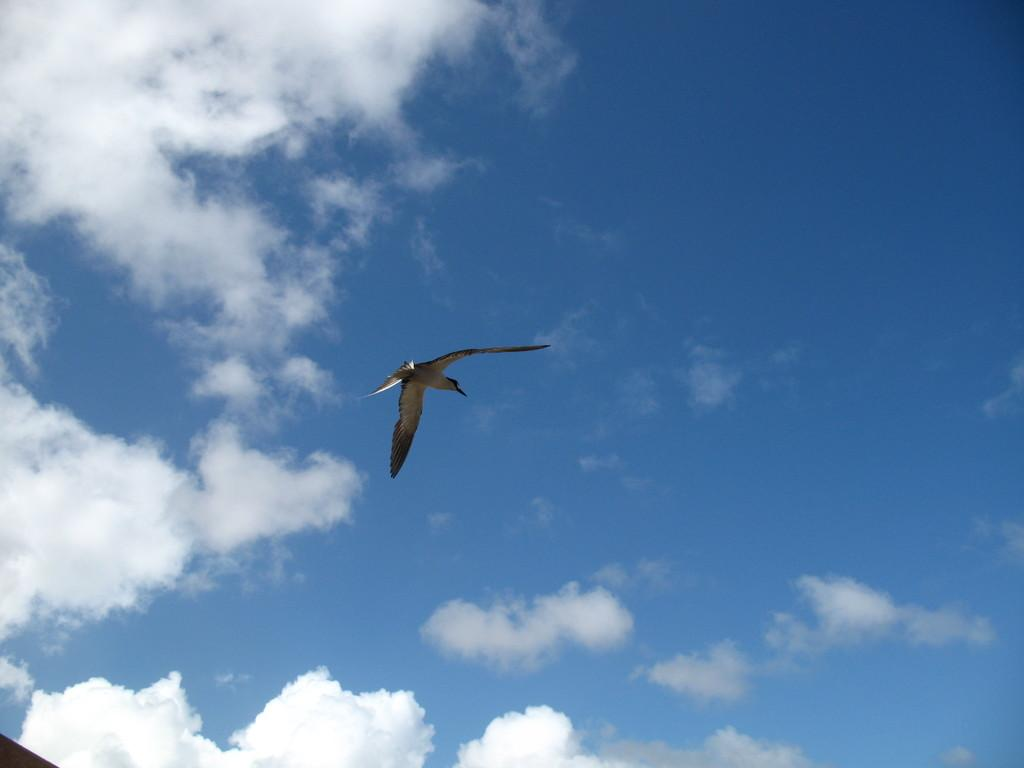What is the main subject of the image? The main subject of the image is a bird flying. Where is the bird located in the image? The bird is in the air in the image. What can be seen in the background of the image? There are clouds and a blue sky visible in the background of the image. What type of metal is the church's bell made of in the image? There is no church or bell present in the image; it features a bird flying in the air. Can you see any yaks in the image? There are no yaks present in the image; it features a bird flying in the air. 